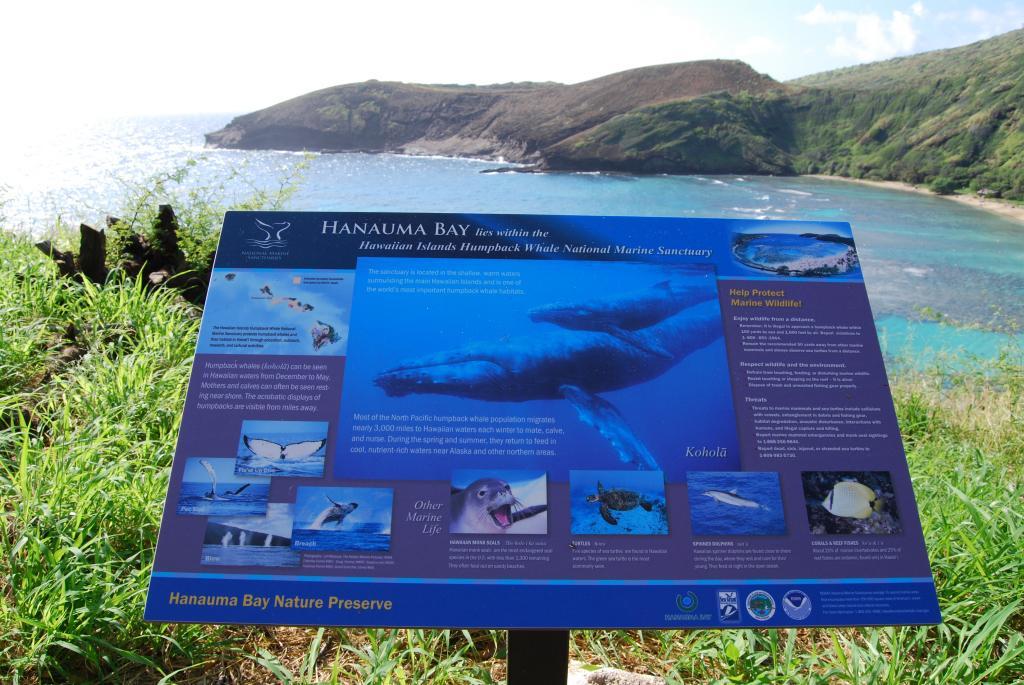How would you summarize this image in a sentence or two? In this image I can see a board which is blue in color and I can see few animal pictures on the board. In the background I can see some grass, some water, a mountain and the sky. 